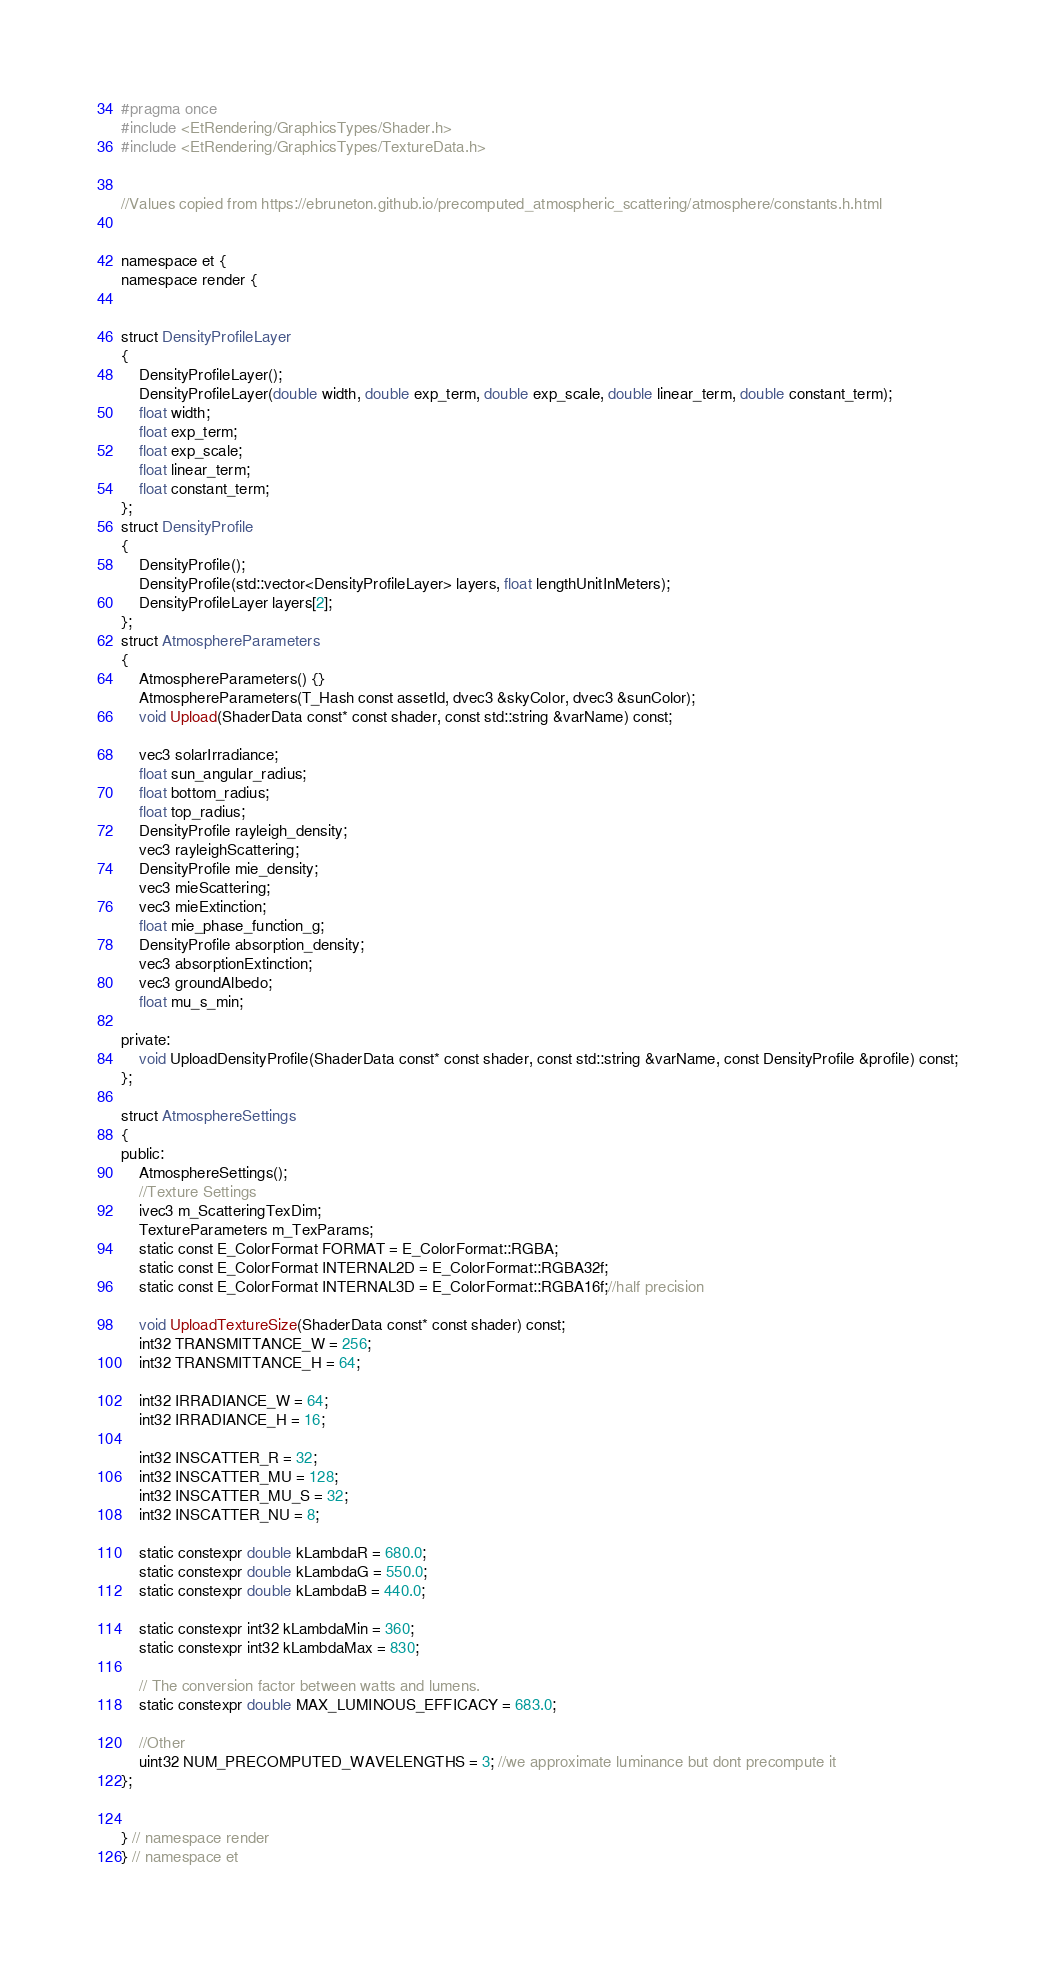Convert code to text. <code><loc_0><loc_0><loc_500><loc_500><_C_>#pragma once
#include <EtRendering/GraphicsTypes/Shader.h>
#include <EtRendering/GraphicsTypes/TextureData.h>


//Values copied from https://ebruneton.github.io/precomputed_atmospheric_scattering/atmosphere/constants.h.html


namespace et {
namespace render { 


struct DensityProfileLayer
{
	DensityProfileLayer();
	DensityProfileLayer(double width, double exp_term, double exp_scale, double linear_term, double constant_term);
	float width;
	float exp_term;
	float exp_scale;
	float linear_term;
	float constant_term;
};
struct DensityProfile
{
	DensityProfile();
	DensityProfile(std::vector<DensityProfileLayer> layers, float lengthUnitInMeters);
	DensityProfileLayer layers[2];
};
struct AtmosphereParameters
{
	AtmosphereParameters() {}
	AtmosphereParameters(T_Hash const assetId, dvec3 &skyColor, dvec3 &sunColor);
	void Upload(ShaderData const* const shader, const std::string &varName) const;

	vec3 solarIrradiance;
	float sun_angular_radius;
	float bottom_radius;
	float top_radius;
	DensityProfile rayleigh_density;
	vec3 rayleighScattering;
	DensityProfile mie_density;
	vec3 mieScattering;
	vec3 mieExtinction;
	float mie_phase_function_g;
	DensityProfile absorption_density;
	vec3 absorptionExtinction;
	vec3 groundAlbedo;
	float mu_s_min;

private:
	void UploadDensityProfile(ShaderData const* const shader, const std::string &varName, const DensityProfile &profile) const;
};

struct AtmosphereSettings
{
public:
	AtmosphereSettings();
	//Texture Settings
	ivec3 m_ScatteringTexDim;
	TextureParameters m_TexParams;
	static const E_ColorFormat FORMAT = E_ColorFormat::RGBA;
	static const E_ColorFormat INTERNAL2D = E_ColorFormat::RGBA32f;
	static const E_ColorFormat INTERNAL3D = E_ColorFormat::RGBA16f;//half precision

	void UploadTextureSize(ShaderData const* const shader) const;
	int32 TRANSMITTANCE_W = 256;
	int32 TRANSMITTANCE_H = 64;

	int32 IRRADIANCE_W = 64;
	int32 IRRADIANCE_H = 16;

	int32 INSCATTER_R = 32;
	int32 INSCATTER_MU = 128;
	int32 INSCATTER_MU_S = 32;
	int32 INSCATTER_NU = 8;

	static constexpr double kLambdaR = 680.0;
	static constexpr double kLambdaG = 550.0;
	static constexpr double kLambdaB = 440.0;

	static constexpr int32 kLambdaMin = 360;
	static constexpr int32 kLambdaMax = 830;

	// The conversion factor between watts and lumens.
	static constexpr double MAX_LUMINOUS_EFFICACY = 683.0;

	//Other
	uint32 NUM_PRECOMPUTED_WAVELENGTHS = 3; //we approximate luminance but dont precompute it
};


} // namespace render
} // namespace et
</code> 